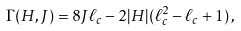Convert formula to latex. <formula><loc_0><loc_0><loc_500><loc_500>\Gamma ( H , J ) = 8 J \ell _ { c } - 2 | H | ( \ell _ { c } ^ { 2 } - \ell _ { c } + 1 ) \, ,</formula> 